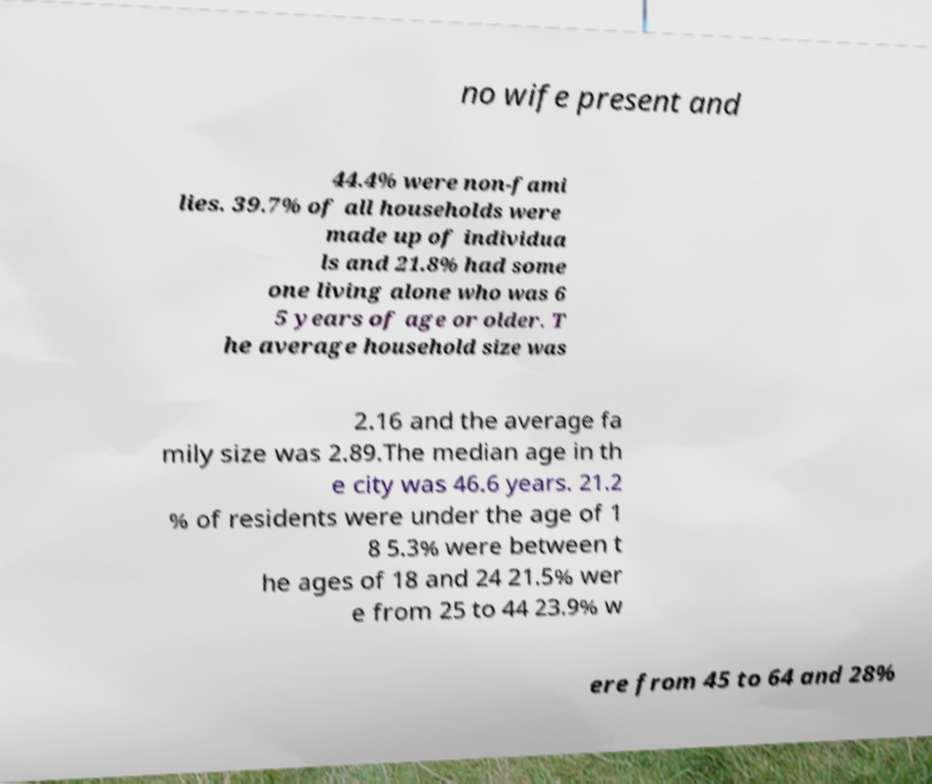I need the written content from this picture converted into text. Can you do that? no wife present and 44.4% were non-fami lies. 39.7% of all households were made up of individua ls and 21.8% had some one living alone who was 6 5 years of age or older. T he average household size was 2.16 and the average fa mily size was 2.89.The median age in th e city was 46.6 years. 21.2 % of residents were under the age of 1 8 5.3% were between t he ages of 18 and 24 21.5% wer e from 25 to 44 23.9% w ere from 45 to 64 and 28% 